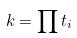<formula> <loc_0><loc_0><loc_500><loc_500>k = \prod t _ { i }</formula> 